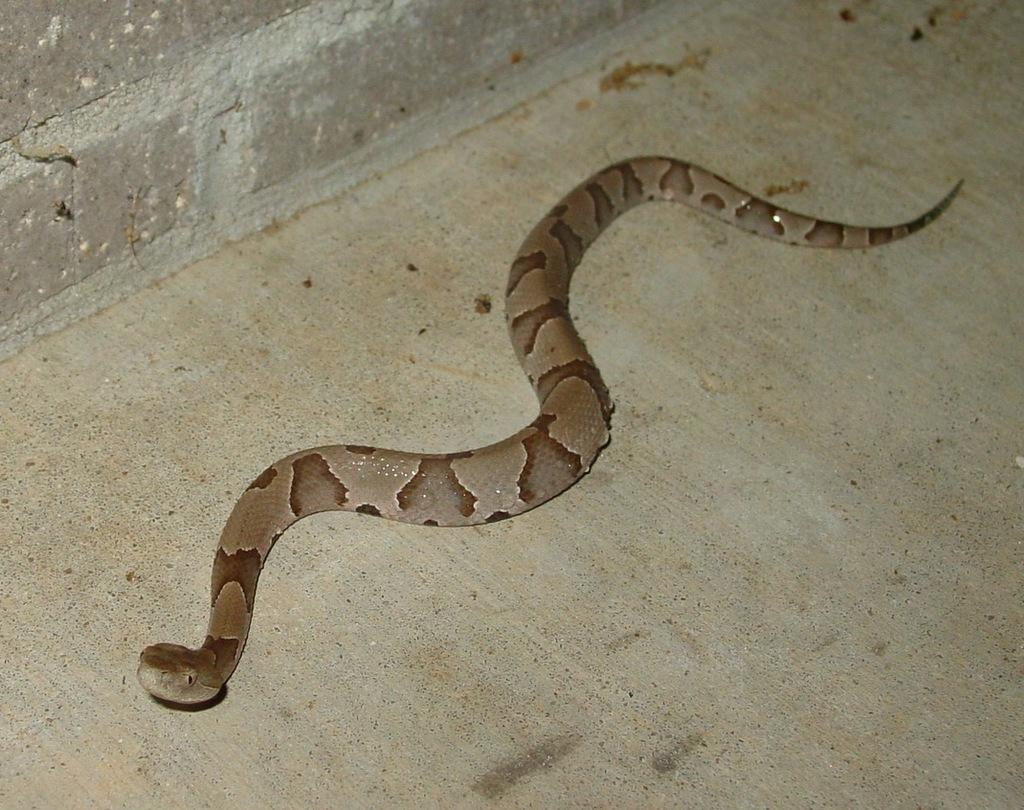How would you summarize this image in a sentence or two? In this image in the center there is a snake. 